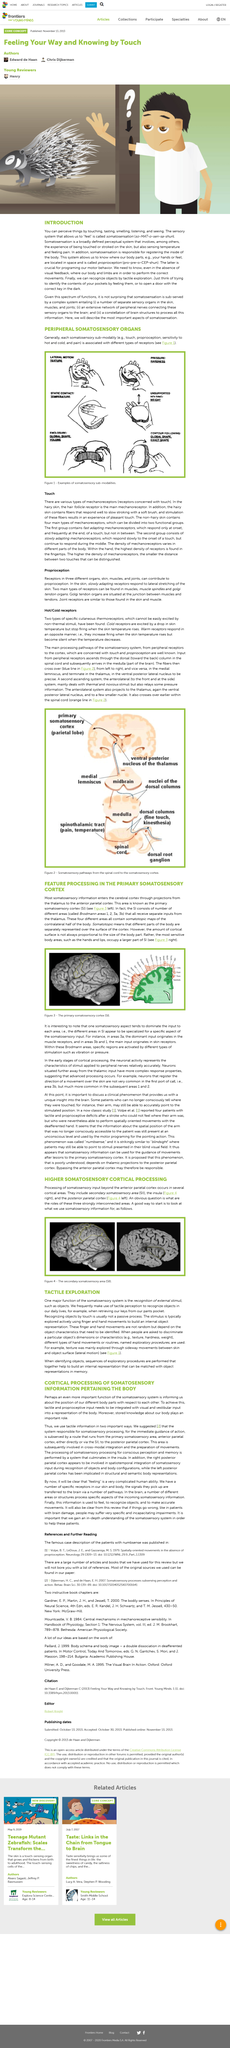Point out several critical features in this image. The figure number of the left illustration showing the primary somatosensory cortex in the text of the article is given as 3. In order to gain a comprehensive understanding of the roles of the three strongly interconnected areas, it is recommended to begin by examining how we utilize somatosensory information in our everyday lives. Stored knowledge about our body plays an important role in our lives. The exploration of the stimulus is typically done actively through finger and hand movements, in order to build an internal object representation. The exploration of texture was conducted through the use of sideway movements between the skin and object surface, which allowed for a thorough examination of the texture. 